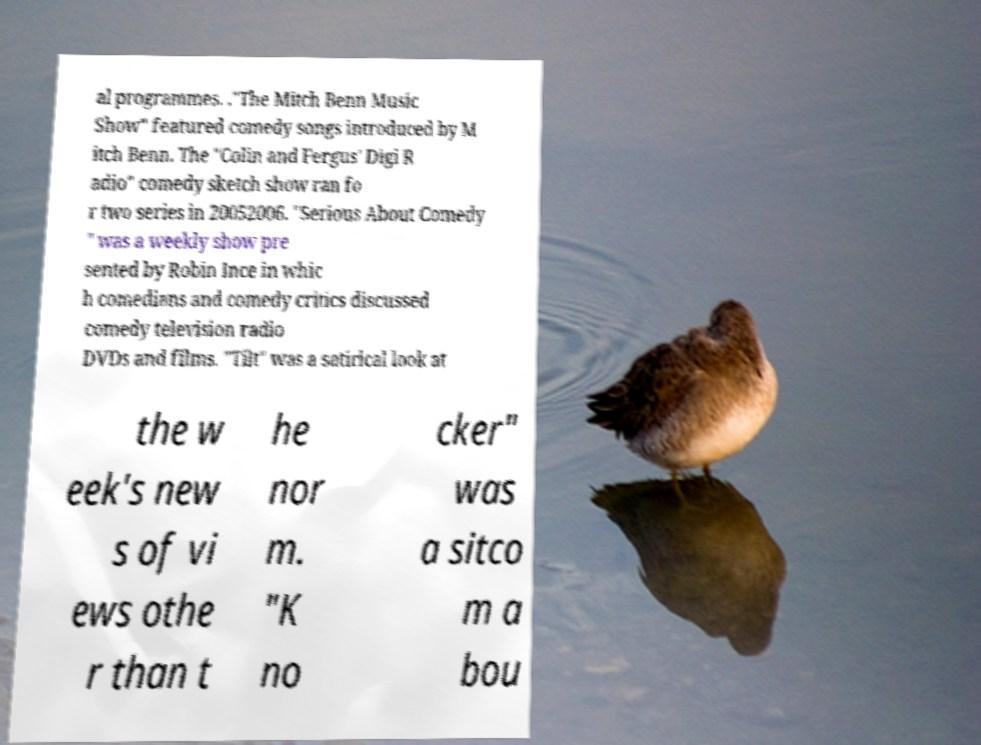Could you assist in decoding the text presented in this image and type it out clearly? al programmes. ."The Mitch Benn Music Show" featured comedy songs introduced by M itch Benn. The "Colin and Fergus' Digi R adio" comedy sketch show ran fo r two series in 20052006. "Serious About Comedy " was a weekly show pre sented by Robin Ince in whic h comedians and comedy critics discussed comedy television radio DVDs and films. "Tilt" was a satirical look at the w eek's new s of vi ews othe r than t he nor m. "K no cker" was a sitco m a bou 